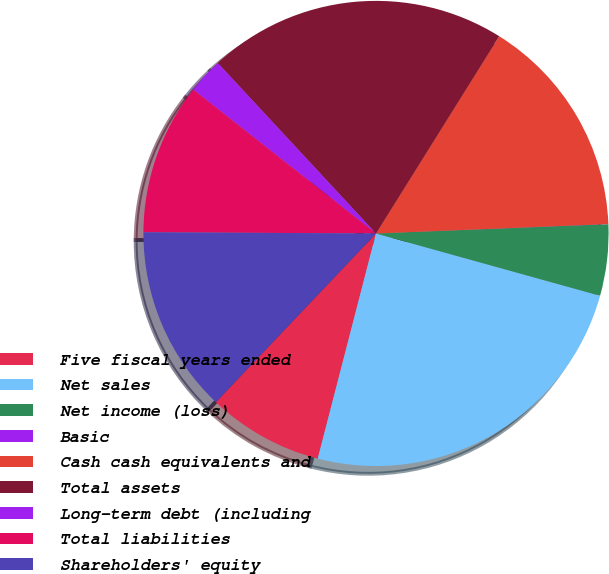<chart> <loc_0><loc_0><loc_500><loc_500><pie_chart><fcel>Five fiscal years ended<fcel>Net sales<fcel>Net income (loss)<fcel>Basic<fcel>Cash cash equivalents and<fcel>Total assets<fcel>Long-term debt (including<fcel>Total liabilities<fcel>Shareholders' equity<nl><fcel>8.06%<fcel>24.72%<fcel>4.95%<fcel>0.01%<fcel>15.47%<fcel>20.8%<fcel>2.48%<fcel>10.53%<fcel>13.0%<nl></chart> 